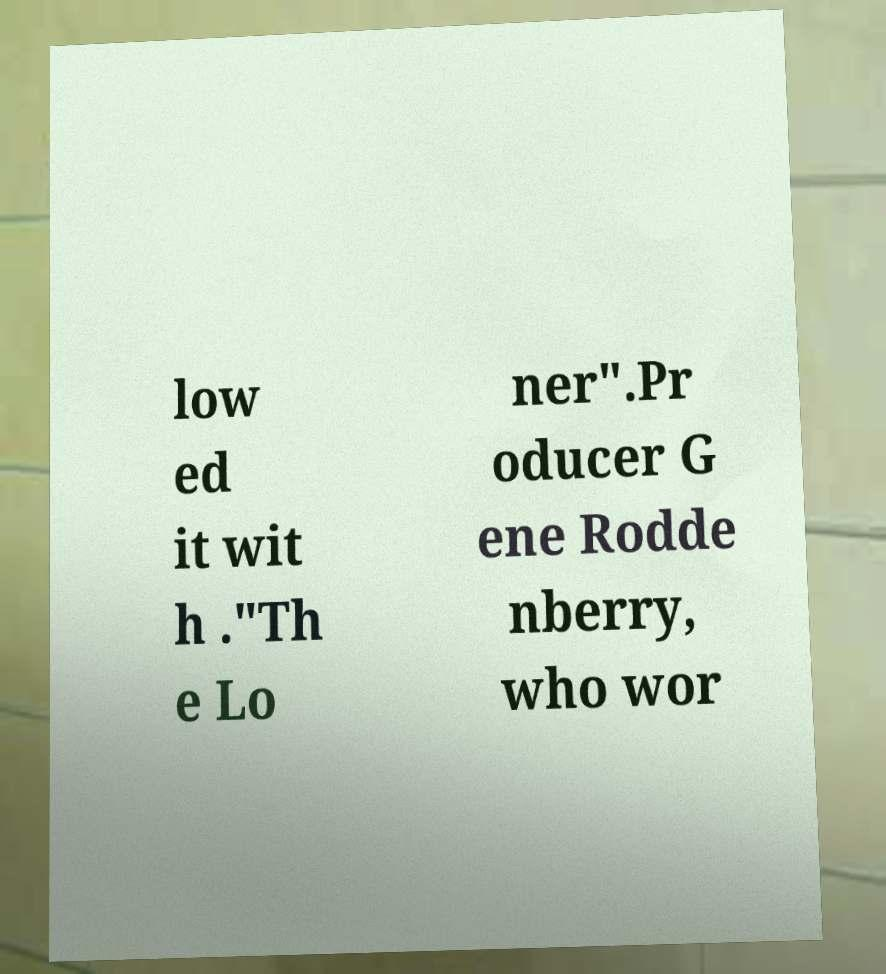What messages or text are displayed in this image? I need them in a readable, typed format. low ed it wit h ."Th e Lo ner".Pr oducer G ene Rodde nberry, who wor 